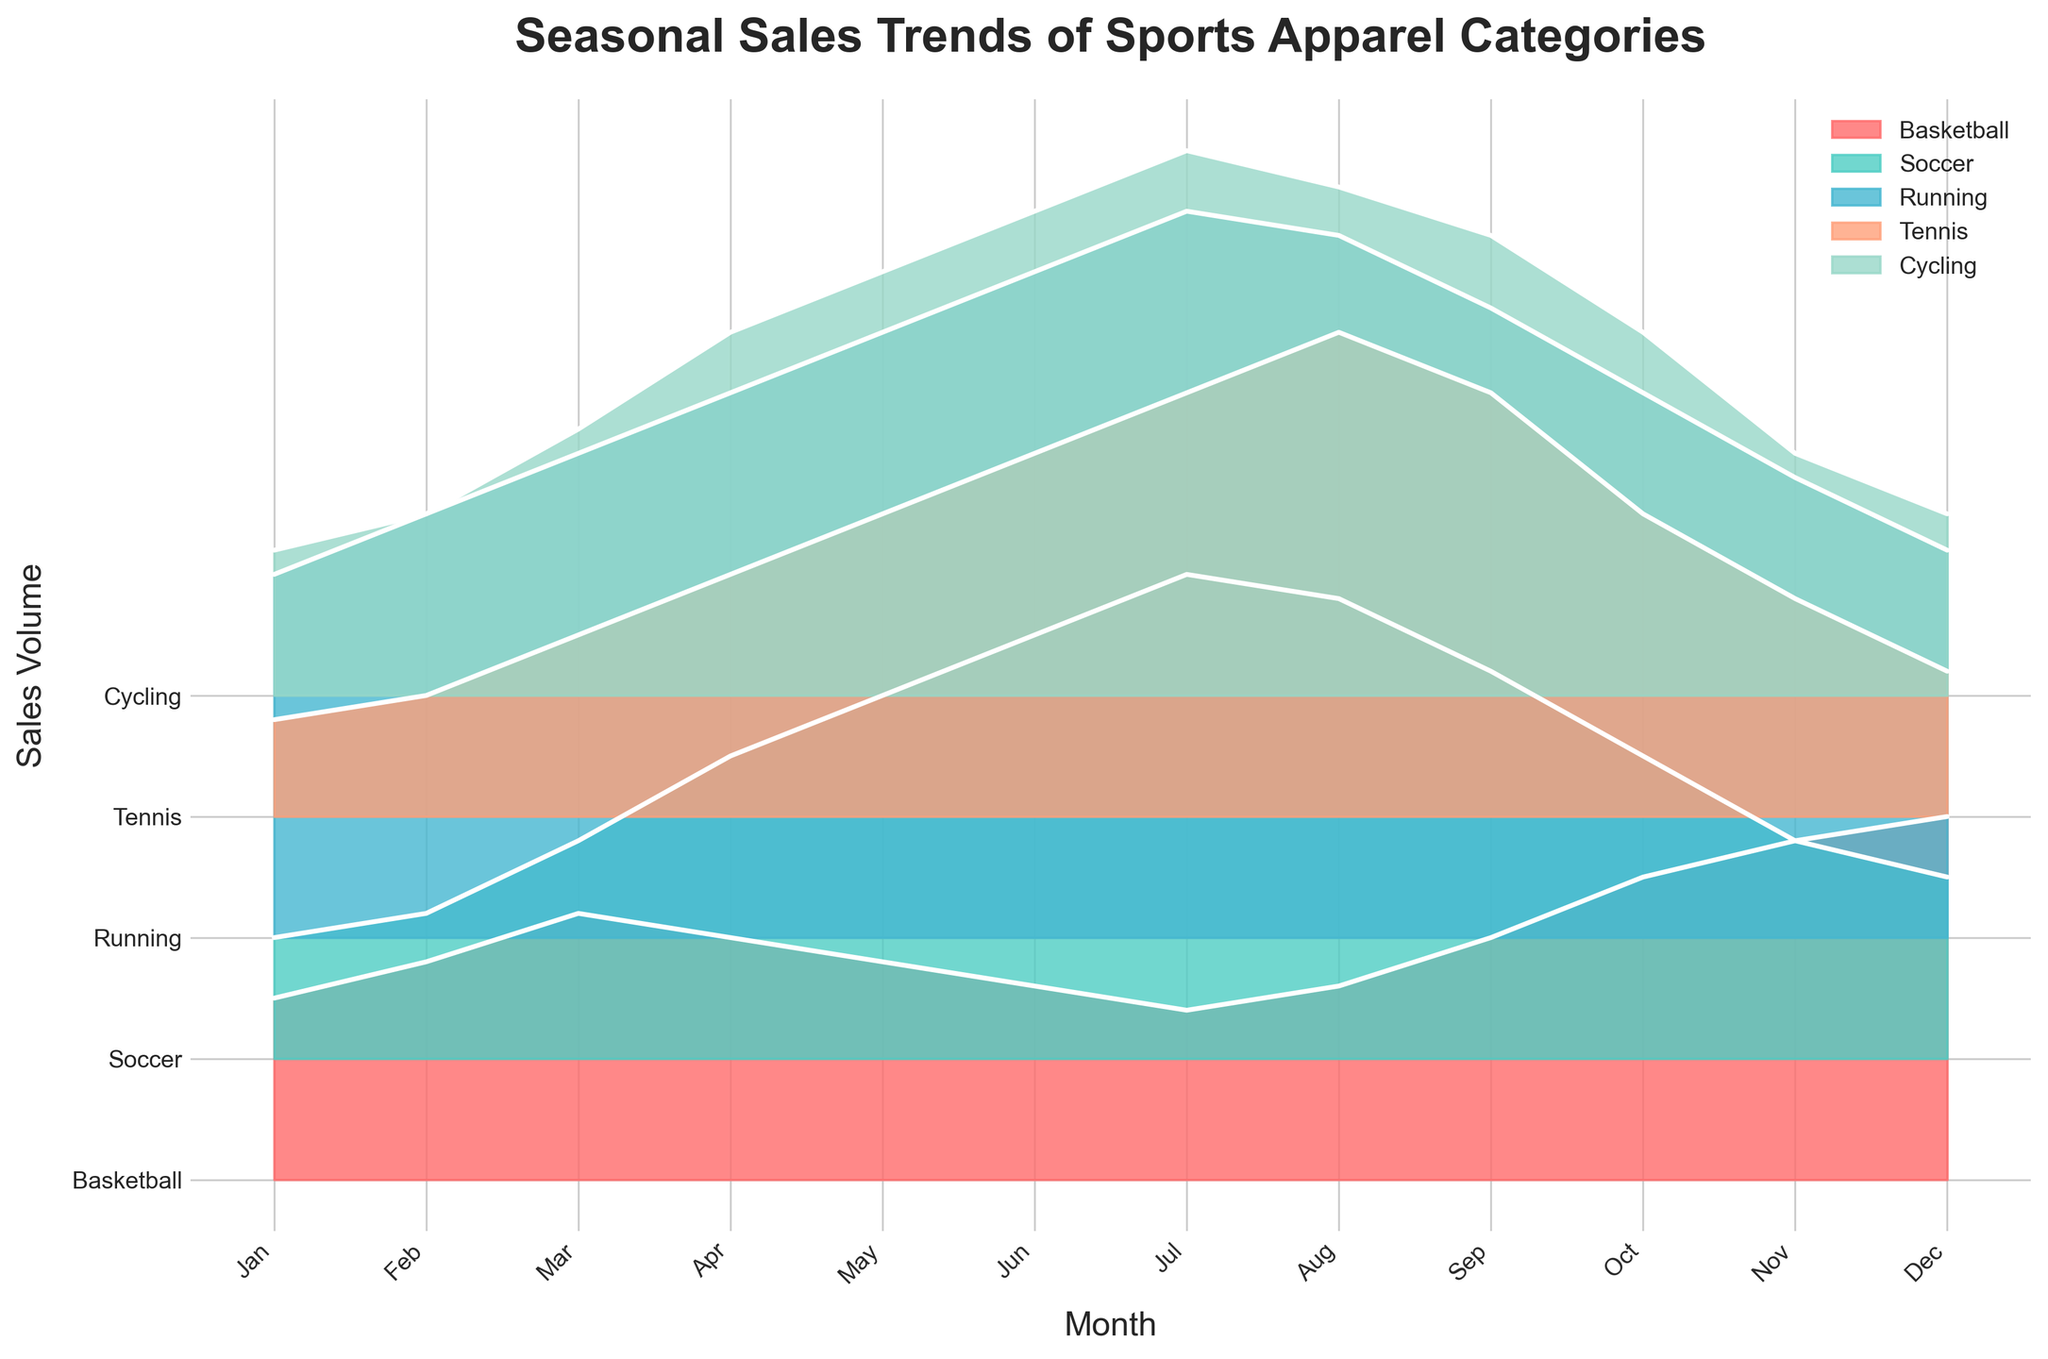What is the title of the plot? The title is usually located at the top of the plot, written in a larger and bolder font. In this case, it clearly states the main topic of the plot.
Answer: Seasonal Sales Trends of Sports Apparel Categories Which month has the highest sales for the Soccer category? To find this, look at the filled area representing the Soccer category and identify the month where the peak is highest. The Soccer category's highest peak appears in July.
Answer: July In which month are Tennis sales higher than Cycling sales? To determine this, compare the heights of the filled areas for Tennis and Cycling month by month. For November, Tennis has 18 while Cycling has 20, so it's lower. July is an example where Tennis at 35 is higher than Cycling at 45.
Answer: July What is the observed trend in Basketball sales over the year? By observing the filled area for the Basketball category from January to December, note that it generally increases, with a peak in December and lower values in the middle of the year.
Answer: Increasing trend On average, which category has the highest sales volume? Calculate the average sales for each category based on the monthly data. Running has the highest repeated peaks compared to other categories consistently throughout the year.
Answer: Running What month shows the highest sales volume for all categories combined? Add the sales volumes of all categories for each month and compare. The totals indicate that August has the combined highest volume (16+38+58+40+42).
Answer: August Which two categories have the closest sales volumes in February? Compare the height of the filled areas for each category in February. Soccer (12) and Tennis (10) are closer compared to other category pairs.
Answer: Soccer and Tennis How do Running sales in March compare with Running sales in June? Identify and compare the heights of Running category's filled areas in March and June. March has 40 units, and June has 55, so June is higher.
Answer: Higher in June Which category has the most significant increase in sales from January to July? Compare the changes in heights from January to July for each category; Cycling increases the most from 12 in January to 45 in July.
Answer: Cycling What seasonal pattern does Cycling category exhibit? Observe and describe the trend in the height of the filled area for the Cycling category across the months. It rises significantly in the first half of the year, peaks in Summer (July-August), and then declines towards Winter (December).
Answer: Peaks in Summer; declines towards Winter 